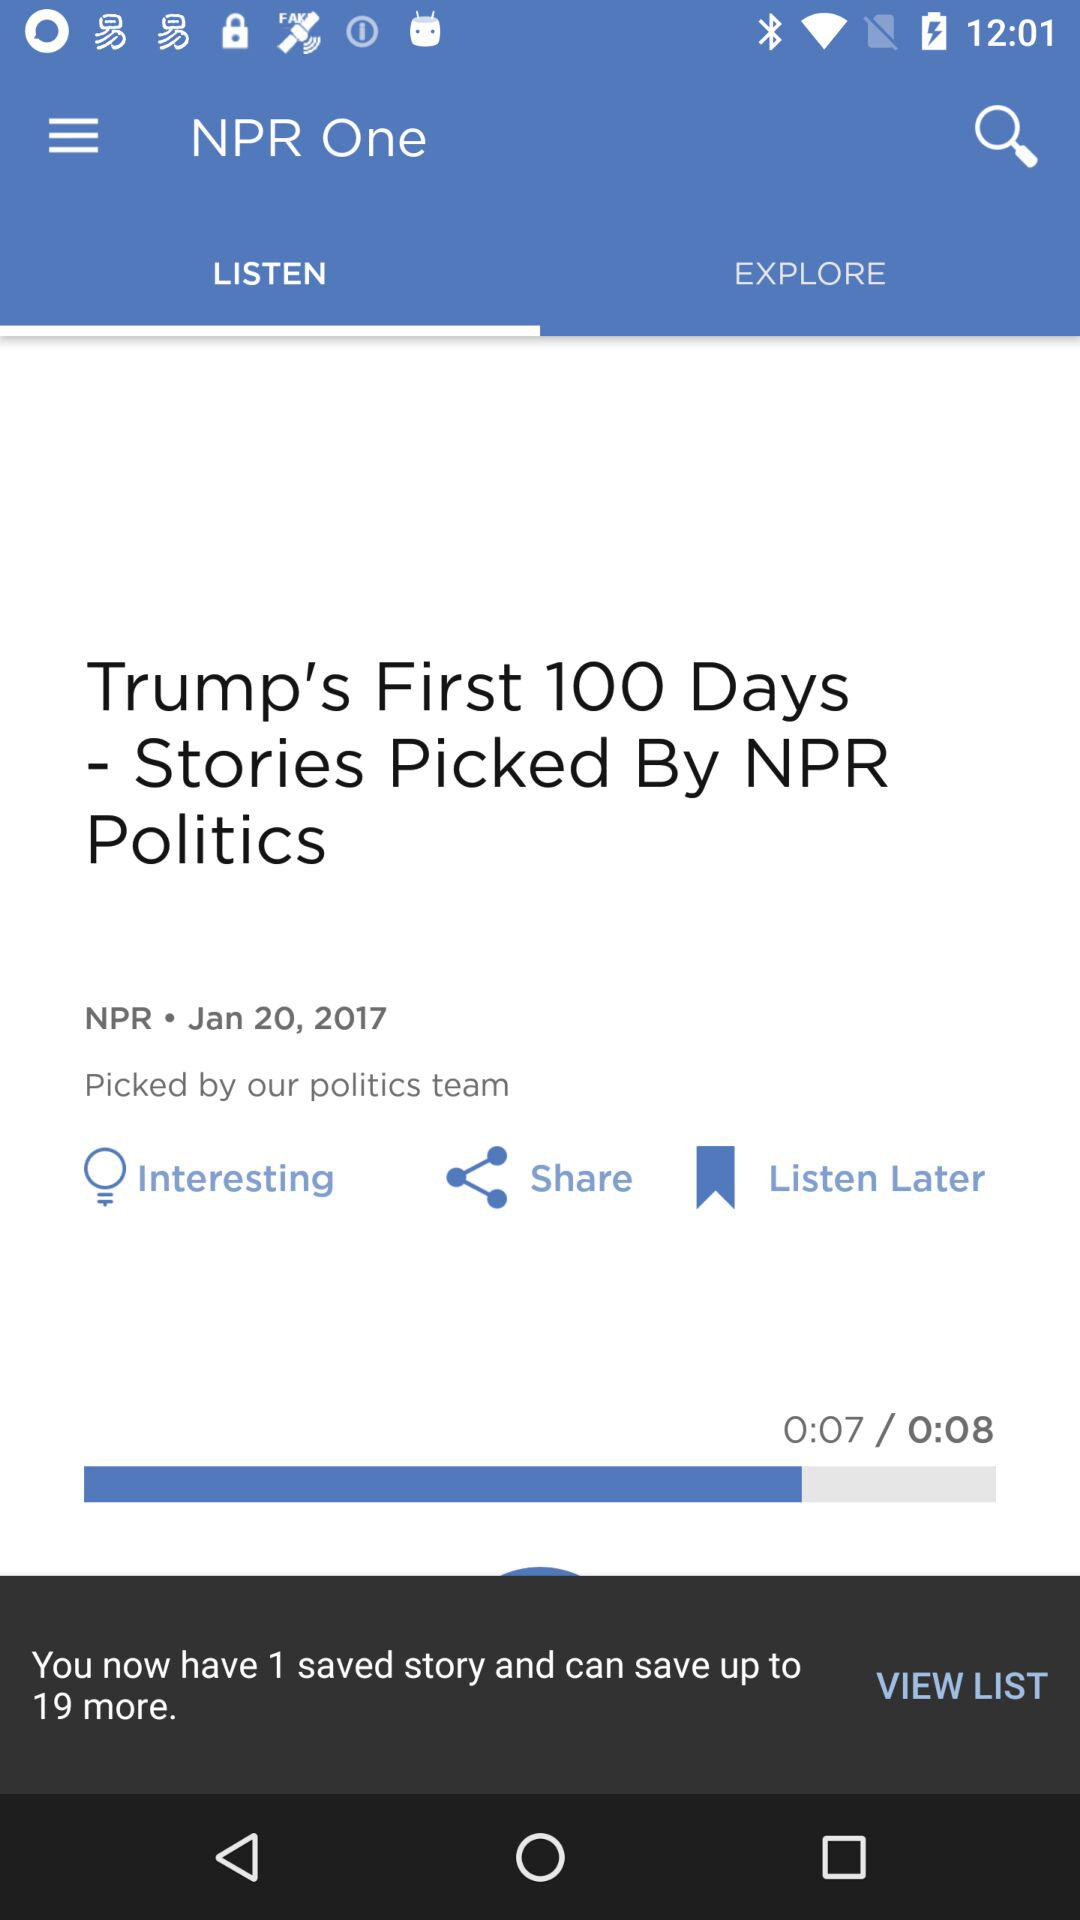How many more stories can I save?
Answer the question using a single word or phrase. 19 